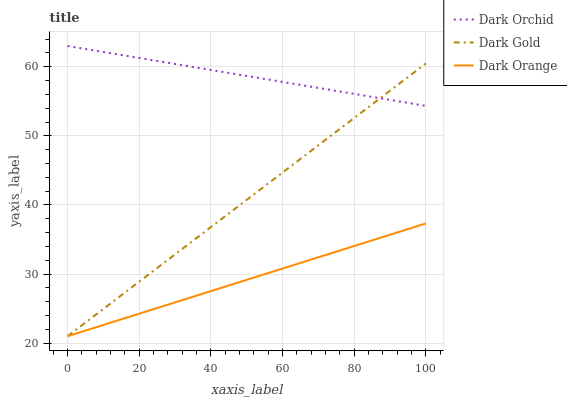Does Dark Gold have the minimum area under the curve?
Answer yes or no. No. Does Dark Gold have the maximum area under the curve?
Answer yes or no. No. Is Dark Gold the smoothest?
Answer yes or no. No. Is Dark Gold the roughest?
Answer yes or no. No. Does Dark Orchid have the lowest value?
Answer yes or no. No. Does Dark Gold have the highest value?
Answer yes or no. No. Is Dark Orange less than Dark Orchid?
Answer yes or no. Yes. Is Dark Orchid greater than Dark Orange?
Answer yes or no. Yes. Does Dark Orange intersect Dark Orchid?
Answer yes or no. No. 